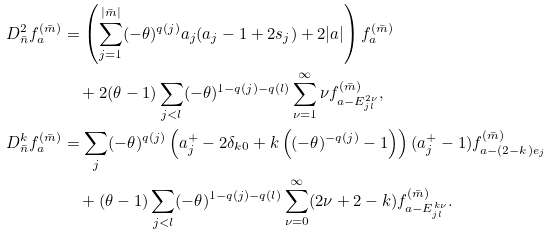<formula> <loc_0><loc_0><loc_500><loc_500>D ^ { 2 } _ { \bar { n } } f ^ { ( \bar { m } ) } _ { a } & = \left ( \sum _ { j = 1 } ^ { | \bar { m } | } ( - \theta ) ^ { q ( j ) } a _ { j } ( a _ { j } - 1 + 2 s _ { j } ) + 2 | a | \right ) f ^ { ( \bar { m } ) } _ { a } \\ & \quad + 2 ( \theta - 1 ) \sum _ { j < l } ( - \theta ) ^ { 1 - q ( j ) - q ( l ) } \sum _ { \nu = 1 } ^ { \infty } \nu f ^ { ( \bar { m } ) } _ { a - E ^ { 2 \nu } _ { j l } } , \\ D ^ { k } _ { \bar { n } } f ^ { ( \bar { m } ) } _ { a } & = \sum _ { j } ( - \theta ) ^ { q ( j ) } \left ( a ^ { + } _ { j } - 2 \delta _ { k 0 } + k \left ( ( - \theta ) ^ { - q ( j ) } - 1 \right ) \right ) ( a ^ { + } _ { j } - 1 ) f ^ { ( \bar { m } ) } _ { a - ( 2 - k ) e _ { j } } \\ & \quad + ( \theta - 1 ) \sum _ { j < l } ( - \theta ) ^ { 1 - q ( j ) - q ( l ) } \sum _ { \nu = 0 } ^ { \infty } ( 2 \nu + 2 - k ) f ^ { ( \bar { m } ) } _ { a - E ^ { k \nu } _ { j l } } .</formula> 